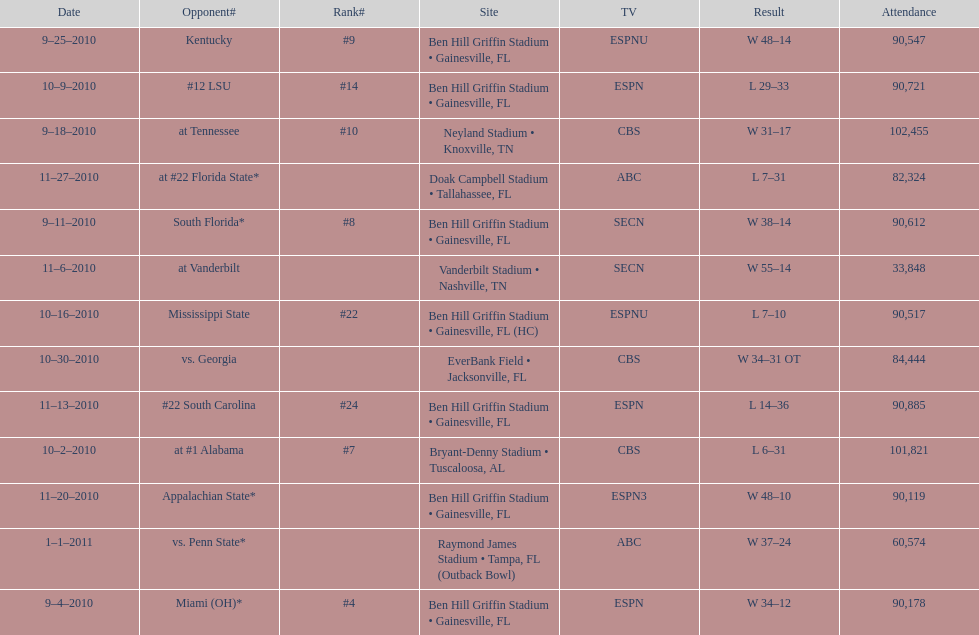How many games did the university of florida win by at least 10 points? 7. 